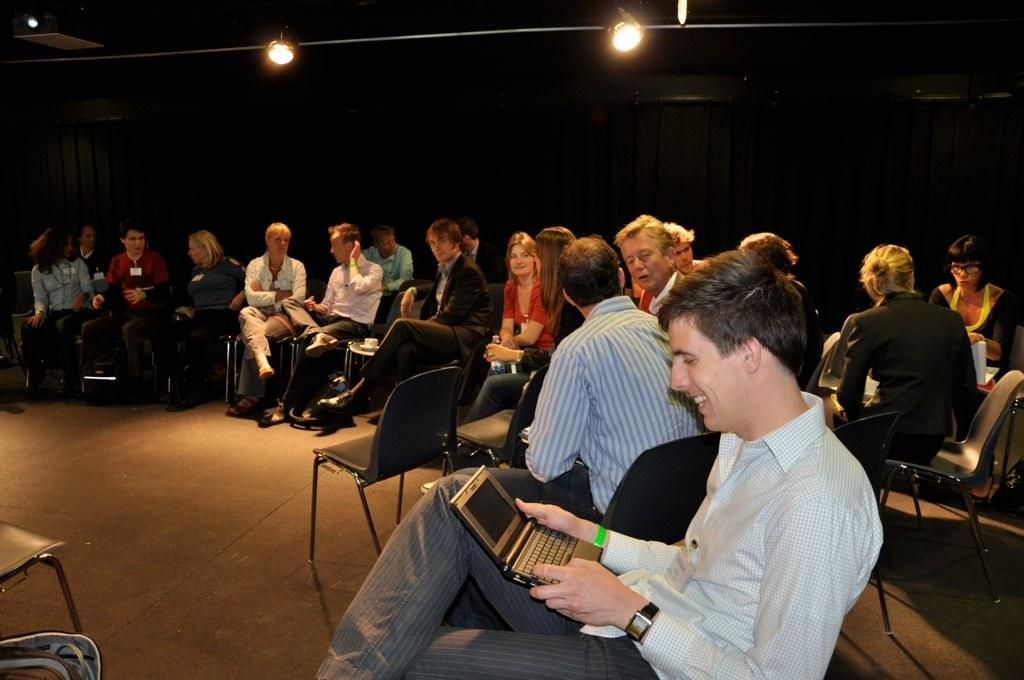How many people are sitting in the image? There are many persons sitting on chairs in the image. What can be seen in the background of the image? There is a curtain and lights visible in the background of the image. What is the distribution of the chairs in the image? The distribution of the chairs cannot be determined from the image alone, as it only shows the chairs and people sitting on them. --- Facts: 1. There is a person holding a book in the image. 2. The person is sitting on a couch. 3. There is a table next to the couch. 4. There is a lamp on the table. Absurd Topics: dance, ocean, parrot Conversation: What is the person in the image holding? The person is holding a book in the image. Where is the person sitting? The person is sitting on a couch. What is located next to the couch? There is a table next to the couch. What can be seen on the table? There is a lamp on the table. Reasoning: Let's think step by step in order to produce the conversation. We start by identifying the main subject in the image, which is the person holding a book. Then, we expand the conversation to include other details about the image, such as the couch, table, and lamp. Each question is designed to elicit a specific detail about the image that is known from the provided facts. Absurd Question/Answer: Can you see any parrots in the image? No, there are no parrots present in the image. 